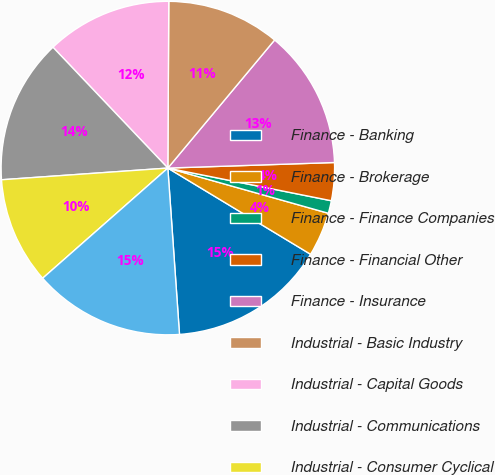Convert chart. <chart><loc_0><loc_0><loc_500><loc_500><pie_chart><fcel>Finance - Banking<fcel>Finance - Brokerage<fcel>Finance - Finance Companies<fcel>Finance - Financial Other<fcel>Finance - Insurance<fcel>Industrial - Basic Industry<fcel>Industrial - Capital Goods<fcel>Industrial - Communications<fcel>Industrial - Consumer Cyclical<fcel>Industrial - Consumer<nl><fcel>15.24%<fcel>4.28%<fcel>1.23%<fcel>3.67%<fcel>13.41%<fcel>10.97%<fcel>12.19%<fcel>14.02%<fcel>10.37%<fcel>14.63%<nl></chart> 